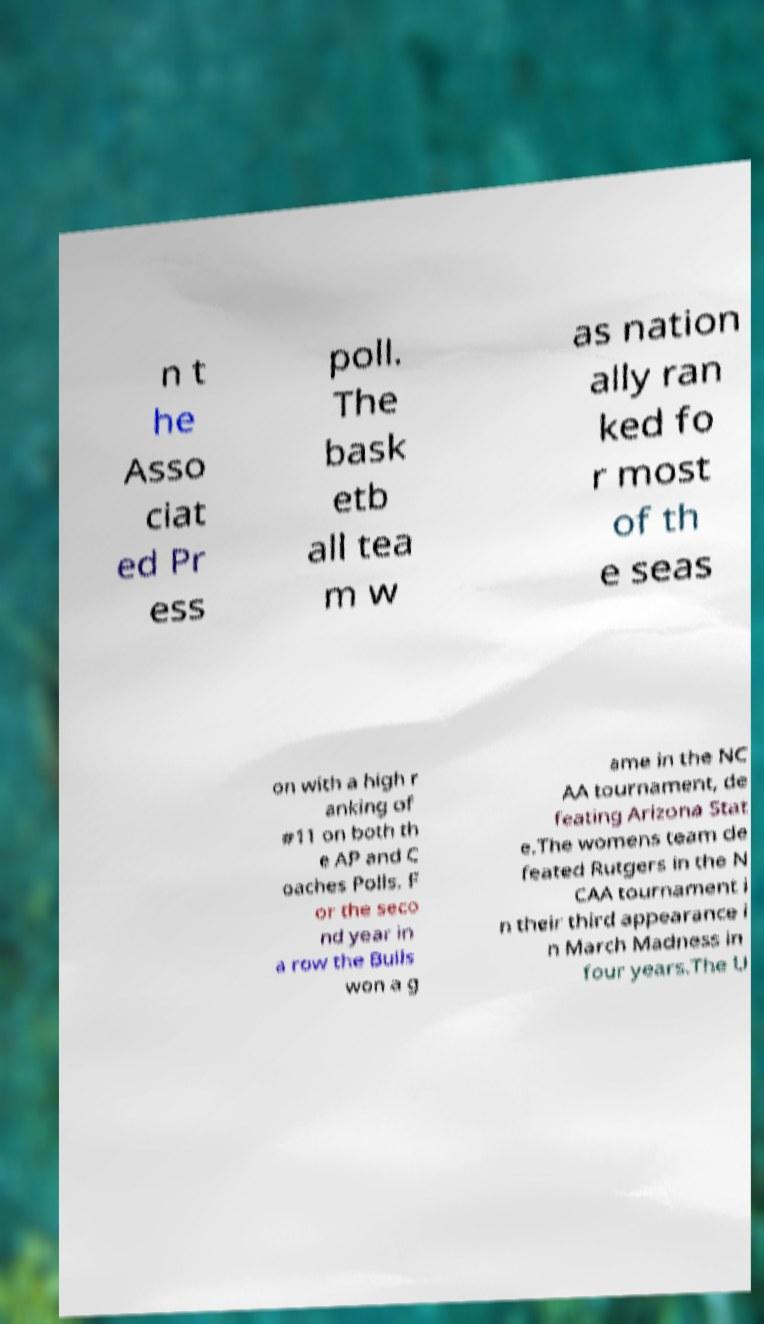For documentation purposes, I need the text within this image transcribed. Could you provide that? n t he Asso ciat ed Pr ess poll. The bask etb all tea m w as nation ally ran ked fo r most of th e seas on with a high r anking of #11 on both th e AP and C oaches Polls. F or the seco nd year in a row the Bulls won a g ame in the NC AA tournament, de feating Arizona Stat e.The womens team de feated Rutgers in the N CAA tournament i n their third appearance i n March Madness in four years.The U 